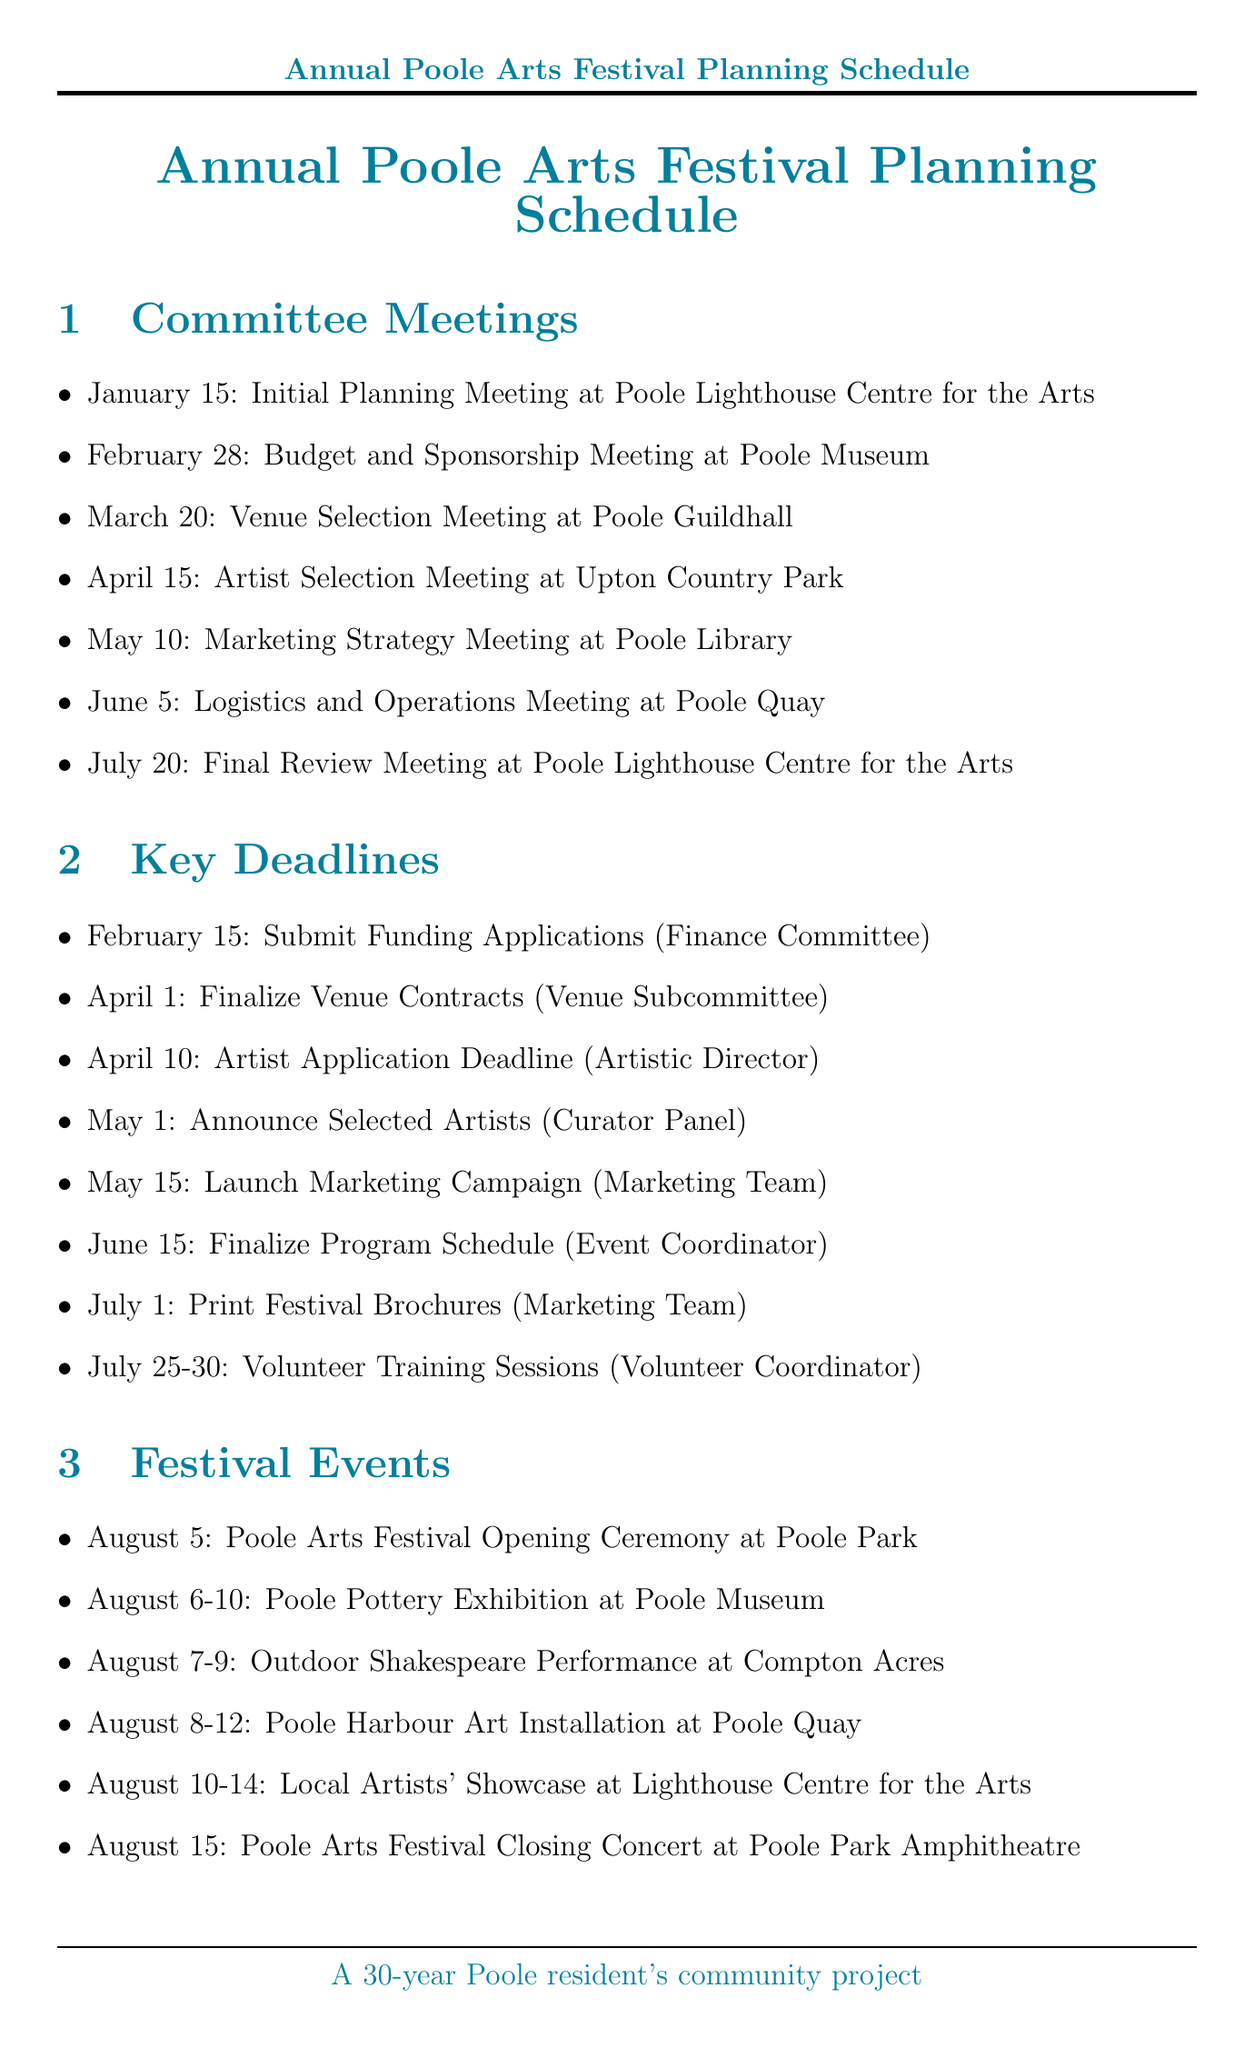what is the date of the Initial Planning Meeting? The date is specified in the committee meetings section of the document.
Answer: January 15 where is the Budget and Sponsorship Meeting held? The location is highlighted in the committee meetings section.
Answer: Poole Museum what is the deadline for submitting funding applications? The deadline is listed under the key deadlines section of the document.
Answer: February 15 who is responsible for finalizing venue contracts? This information can be found next to the corresponding deadline in the document.
Answer: Venue Subcommittee when does the Community Mural Project start? The start date is mentioned in the community involvement section.
Answer: July 15 what is the date range for the Poole Pottery Exhibition? This range is provided in the festival events section.
Answer: August 6-10 how long is the Volunteer Recruitment Drive scheduled? The schedule for this event is in the community involvement section.
Answer: May 1 - July 15 which event is scheduled last on the festival calendar? The last event is specified in the festival events section of the document.
Answer: Poole Arts Festival Closing Concert 